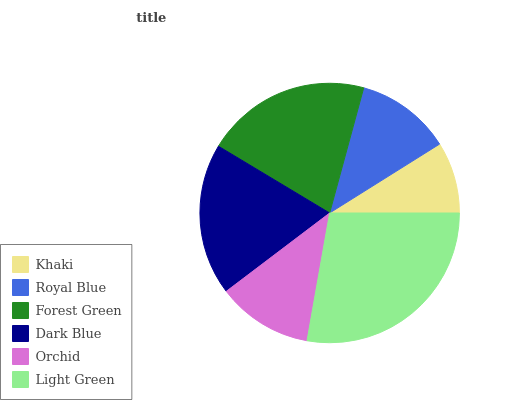Is Khaki the minimum?
Answer yes or no. Yes. Is Light Green the maximum?
Answer yes or no. Yes. Is Royal Blue the minimum?
Answer yes or no. No. Is Royal Blue the maximum?
Answer yes or no. No. Is Royal Blue greater than Khaki?
Answer yes or no. Yes. Is Khaki less than Royal Blue?
Answer yes or no. Yes. Is Khaki greater than Royal Blue?
Answer yes or no. No. Is Royal Blue less than Khaki?
Answer yes or no. No. Is Dark Blue the high median?
Answer yes or no. Yes. Is Orchid the low median?
Answer yes or no. Yes. Is Royal Blue the high median?
Answer yes or no. No. Is Forest Green the low median?
Answer yes or no. No. 